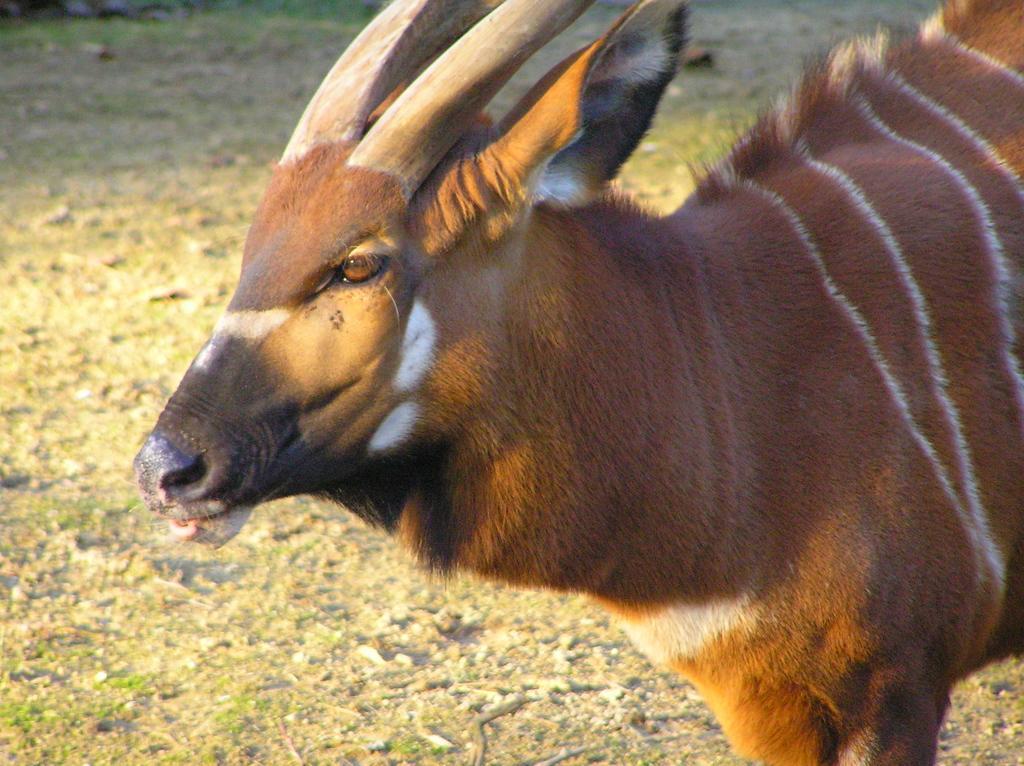In one or two sentences, can you explain what this image depicts? In this image we can see a bull standing on the ground. 